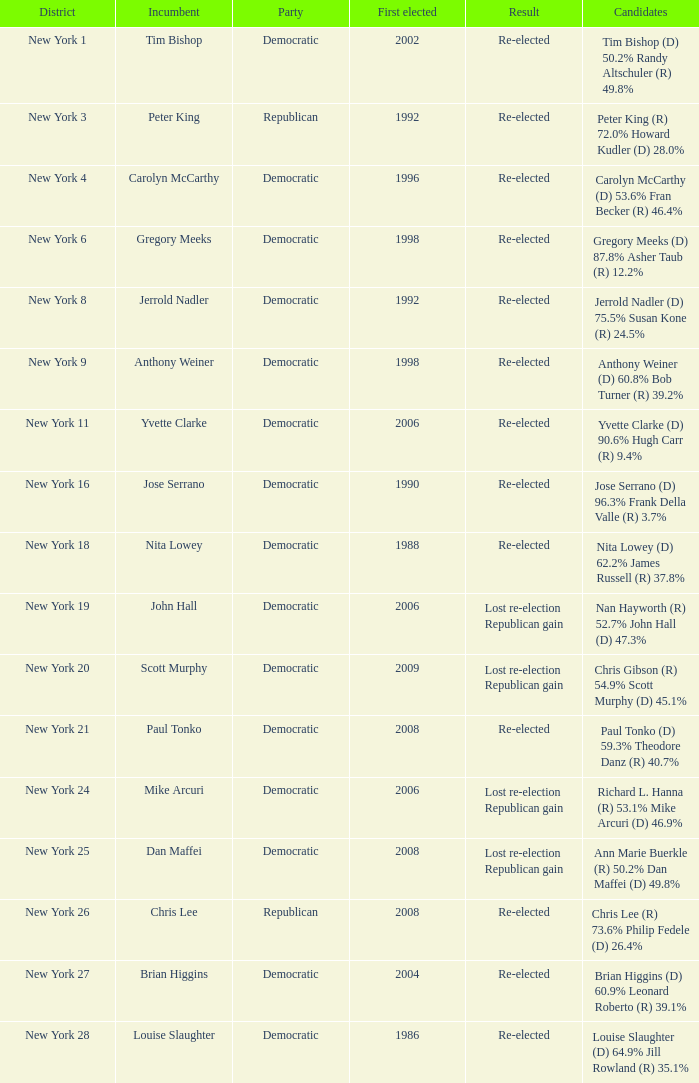Give me the full table as a dictionary. {'header': ['District', 'Incumbent', 'Party', 'First elected', 'Result', 'Candidates'], 'rows': [['New York 1', 'Tim Bishop', 'Democratic', '2002', 'Re-elected', 'Tim Bishop (D) 50.2% Randy Altschuler (R) 49.8%'], ['New York 3', 'Peter King', 'Republican', '1992', 'Re-elected', 'Peter King (R) 72.0% Howard Kudler (D) 28.0%'], ['New York 4', 'Carolyn McCarthy', 'Democratic', '1996', 'Re-elected', 'Carolyn McCarthy (D) 53.6% Fran Becker (R) 46.4%'], ['New York 6', 'Gregory Meeks', 'Democratic', '1998', 'Re-elected', 'Gregory Meeks (D) 87.8% Asher Taub (R) 12.2%'], ['New York 8', 'Jerrold Nadler', 'Democratic', '1992', 'Re-elected', 'Jerrold Nadler (D) 75.5% Susan Kone (R) 24.5%'], ['New York 9', 'Anthony Weiner', 'Democratic', '1998', 'Re-elected', 'Anthony Weiner (D) 60.8% Bob Turner (R) 39.2%'], ['New York 11', 'Yvette Clarke', 'Democratic', '2006', 'Re-elected', 'Yvette Clarke (D) 90.6% Hugh Carr (R) 9.4%'], ['New York 16', 'Jose Serrano', 'Democratic', '1990', 'Re-elected', 'Jose Serrano (D) 96.3% Frank Della Valle (R) 3.7%'], ['New York 18', 'Nita Lowey', 'Democratic', '1988', 'Re-elected', 'Nita Lowey (D) 62.2% James Russell (R) 37.8%'], ['New York 19', 'John Hall', 'Democratic', '2006', 'Lost re-election Republican gain', 'Nan Hayworth (R) 52.7% John Hall (D) 47.3%'], ['New York 20', 'Scott Murphy', 'Democratic', '2009', 'Lost re-election Republican gain', 'Chris Gibson (R) 54.9% Scott Murphy (D) 45.1%'], ['New York 21', 'Paul Tonko', 'Democratic', '2008', 'Re-elected', 'Paul Tonko (D) 59.3% Theodore Danz (R) 40.7%'], ['New York 24', 'Mike Arcuri', 'Democratic', '2006', 'Lost re-election Republican gain', 'Richard L. Hanna (R) 53.1% Mike Arcuri (D) 46.9%'], ['New York 25', 'Dan Maffei', 'Democratic', '2008', 'Lost re-election Republican gain', 'Ann Marie Buerkle (R) 50.2% Dan Maffei (D) 49.8%'], ['New York 26', 'Chris Lee', 'Republican', '2008', 'Re-elected', 'Chris Lee (R) 73.6% Philip Fedele (D) 26.4%'], ['New York 27', 'Brian Higgins', 'Democratic', '2004', 'Re-elected', 'Brian Higgins (D) 60.9% Leonard Roberto (R) 39.1%'], ['New York 28', 'Louise Slaughter', 'Democratic', '1986', 'Re-elected', 'Louise Slaughter (D) 64.9% Jill Rowland (R) 35.1%']]} Identify the outcome for new york Re-elected. 